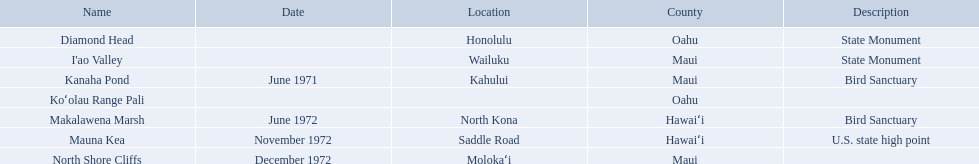What are the different landmark names? Diamond Head, I'ao Valley, Kanaha Pond, Koʻolau Range Pali, Makalawena Marsh, Mauna Kea, North Shore Cliffs. Which of these is located in the county hawai`i? Makalawena Marsh, Mauna Kea. Which of these is not mauna kea? Makalawena Marsh. What are all of the national natural landmarks in hawaii? Diamond Head, I'ao Valley, Kanaha Pond, Koʻolau Range Pali, Makalawena Marsh, Mauna Kea, North Shore Cliffs. Which ones of those national natural landmarks in hawaii are in the county of hawai'i? Makalawena Marsh, Mauna Kea. Which is the only national natural landmark in hawaii that is also a u.s. state high point? Mauna Kea. 